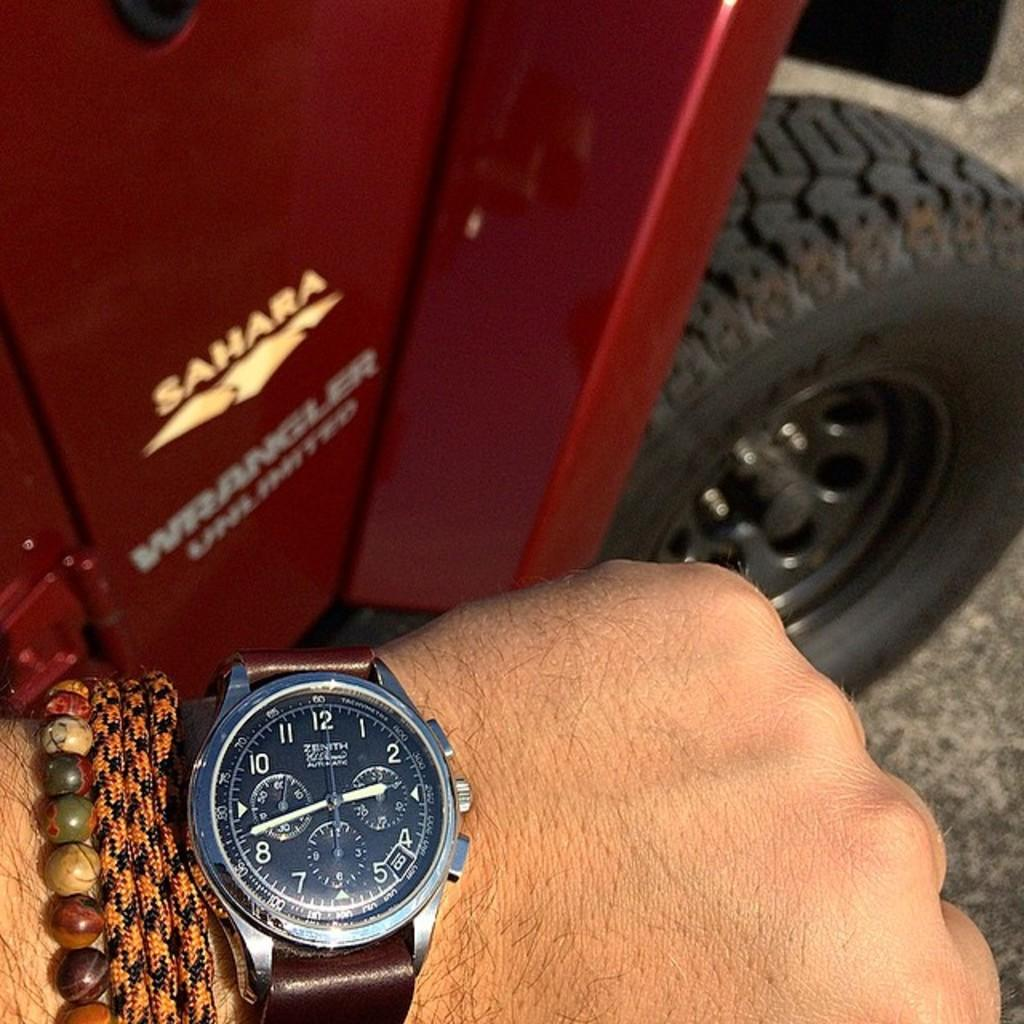<image>
Relay a brief, clear account of the picture shown. The Sahara Jeep Wrangler is great for going off road. 